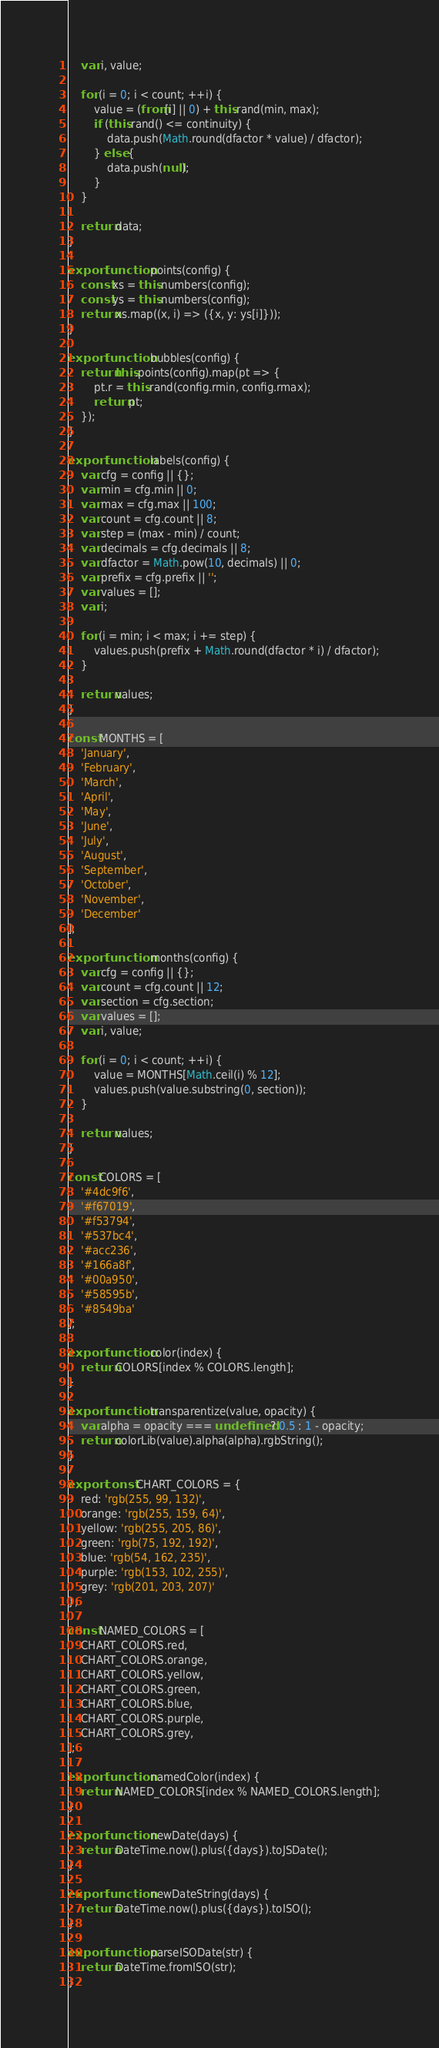Convert code to text. <code><loc_0><loc_0><loc_500><loc_500><_JavaScript_>    var i, value;

    for (i = 0; i < count; ++i) {
        value = (from[i] || 0) + this.rand(min, max);
        if (this.rand() <= continuity) {
            data.push(Math.round(dfactor * value) / dfactor);
        } else {
            data.push(null);
        }
    }

    return data;
}

export function points(config) {
    const xs = this.numbers(config);
    const ys = this.numbers(config);
    return xs.map((x, i) => ({x, y: ys[i]}));
}

export function bubbles(config) {
    return this.points(config).map(pt => {
        pt.r = this.rand(config.rmin, config.rmax);
        return pt;
    });
}

export function labels(config) {
    var cfg = config || {};
    var min = cfg.min || 0;
    var max = cfg.max || 100;
    var count = cfg.count || 8;
    var step = (max - min) / count;
    var decimals = cfg.decimals || 8;
    var dfactor = Math.pow(10, decimals) || 0;
    var prefix = cfg.prefix || '';
    var values = [];
    var i;

    for (i = min; i < max; i += step) {
        values.push(prefix + Math.round(dfactor * i) / dfactor);
    }

    return values;
}

const MONTHS = [
    'January',
    'February',
    'March',
    'April',
    'May',
    'June',
    'July',
    'August',
    'September',
    'October',
    'November',
    'December'
];

export function months(config) {
    var cfg = config || {};
    var count = cfg.count || 12;
    var section = cfg.section;
    var values = [];
    var i, value;

    for (i = 0; i < count; ++i) {
        value = MONTHS[Math.ceil(i) % 12];
        values.push(value.substring(0, section));
    }

    return values;
}

const COLORS = [
    '#4dc9f6',
    '#f67019',
    '#f53794',
    '#537bc4',
    '#acc236',
    '#166a8f',
    '#00a950',
    '#58595b',
    '#8549ba'
];

export function color(index) {
    return COLORS[index % COLORS.length];
}

export function transparentize(value, opacity) {
    var alpha = opacity === undefined ? 0.5 : 1 - opacity;
    return colorLib(value).alpha(alpha).rgbString();
}

export const CHART_COLORS = {
    red: 'rgb(255, 99, 132)',
    orange: 'rgb(255, 159, 64)',
    yellow: 'rgb(255, 205, 86)',
    green: 'rgb(75, 192, 192)',
    blue: 'rgb(54, 162, 235)',
    purple: 'rgb(153, 102, 255)',
    grey: 'rgb(201, 203, 207)'
};

const NAMED_COLORS = [
    CHART_COLORS.red,
    CHART_COLORS.orange,
    CHART_COLORS.yellow,
    CHART_COLORS.green,
    CHART_COLORS.blue,
    CHART_COLORS.purple,
    CHART_COLORS.grey,
];

export function namedColor(index) {
    return NAMED_COLORS[index % NAMED_COLORS.length];
}

export function newDate(days) {
    return DateTime.now().plus({days}).toJSDate();
}

export function newDateString(days) {
    return DateTime.now().plus({days}).toISO();
}

export function parseISODate(str) {
    return DateTime.fromISO(str);
}
</code> 